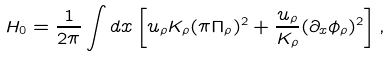Convert formula to latex. <formula><loc_0><loc_0><loc_500><loc_500>H _ { 0 } = \frac { 1 } { 2 \pi } \int d x \left [ u _ { \rho } K _ { \rho } ( \pi \Pi _ { \rho } ) ^ { 2 } + \frac { u _ { \rho } } { K _ { \rho } } ( \partial _ { x } \phi _ { \rho } ) ^ { 2 } \right ] ,</formula> 